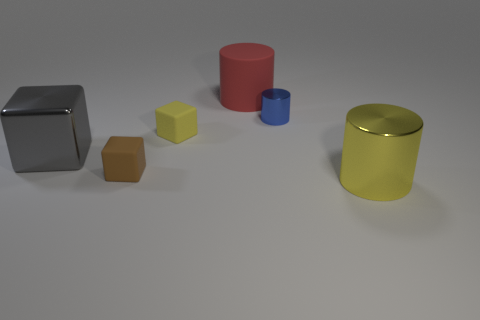Add 2 large yellow cylinders. How many objects exist? 8 Subtract all metal blocks. How many blocks are left? 2 Subtract 3 cylinders. How many cylinders are left? 0 Subtract all yellow cubes. How many cubes are left? 2 Subtract 0 cyan blocks. How many objects are left? 6 Subtract all brown blocks. Subtract all cyan cylinders. How many blocks are left? 2 Subtract all green blocks. How many gray cylinders are left? 0 Subtract all yellow metallic things. Subtract all gray things. How many objects are left? 4 Add 6 large yellow metal cylinders. How many large yellow metal cylinders are left? 7 Add 5 red matte objects. How many red matte objects exist? 6 